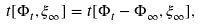Convert formula to latex. <formula><loc_0><loc_0><loc_500><loc_500>t [ \Phi _ { t } , \xi _ { \infty } ] = t [ \Phi _ { t } - \Phi _ { \infty } , \xi _ { \infty } ] ,</formula> 